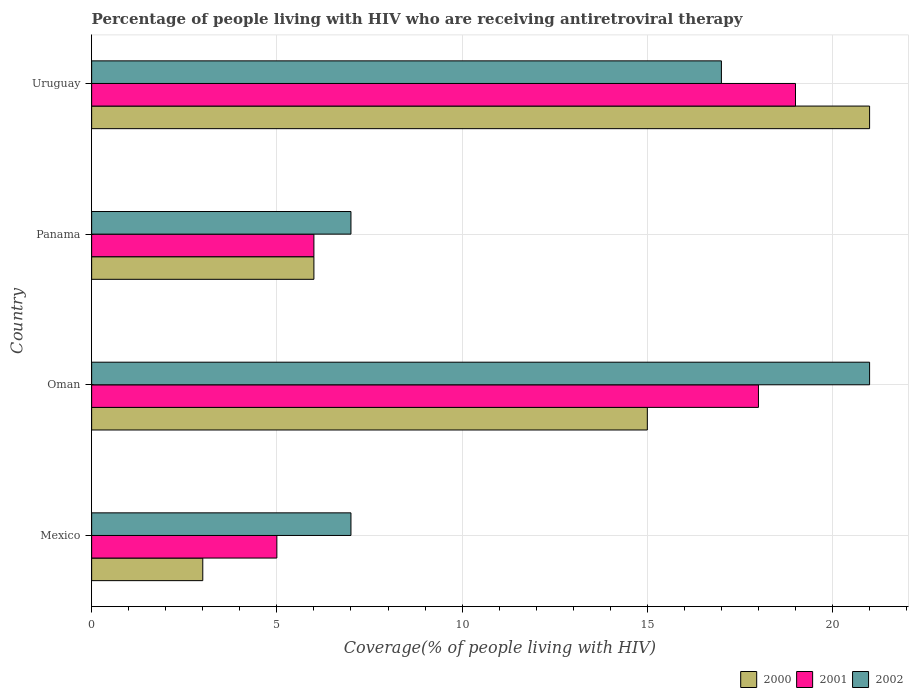How many groups of bars are there?
Offer a very short reply. 4. Are the number of bars per tick equal to the number of legend labels?
Your response must be concise. Yes. Are the number of bars on each tick of the Y-axis equal?
Offer a terse response. Yes. What is the label of the 2nd group of bars from the top?
Make the answer very short. Panama. In how many cases, is the number of bars for a given country not equal to the number of legend labels?
Ensure brevity in your answer.  0. What is the percentage of the HIV infected people who are receiving antiretroviral therapy in 2002 in Oman?
Give a very brief answer. 21. In which country was the percentage of the HIV infected people who are receiving antiretroviral therapy in 2001 maximum?
Ensure brevity in your answer.  Uruguay. What is the total percentage of the HIV infected people who are receiving antiretroviral therapy in 2000 in the graph?
Provide a short and direct response. 45. What is the difference between the percentage of the HIV infected people who are receiving antiretroviral therapy in 2000 in Oman and that in Panama?
Make the answer very short. 9. What is the average percentage of the HIV infected people who are receiving antiretroviral therapy in 2000 per country?
Offer a terse response. 11.25. In how many countries, is the percentage of the HIV infected people who are receiving antiretroviral therapy in 2001 greater than 5 %?
Your response must be concise. 3. What is the ratio of the percentage of the HIV infected people who are receiving antiretroviral therapy in 2002 in Mexico to that in Oman?
Offer a very short reply. 0.33. Is the percentage of the HIV infected people who are receiving antiretroviral therapy in 2001 in Oman less than that in Uruguay?
Offer a very short reply. Yes. What does the 2nd bar from the top in Oman represents?
Ensure brevity in your answer.  2001. Is it the case that in every country, the sum of the percentage of the HIV infected people who are receiving antiretroviral therapy in 2002 and percentage of the HIV infected people who are receiving antiretroviral therapy in 2000 is greater than the percentage of the HIV infected people who are receiving antiretroviral therapy in 2001?
Your response must be concise. Yes. Are all the bars in the graph horizontal?
Ensure brevity in your answer.  Yes. What is the difference between two consecutive major ticks on the X-axis?
Your answer should be compact. 5. Does the graph contain any zero values?
Your response must be concise. No. What is the title of the graph?
Your answer should be very brief. Percentage of people living with HIV who are receiving antiretroviral therapy. Does "1970" appear as one of the legend labels in the graph?
Provide a short and direct response. No. What is the label or title of the X-axis?
Your answer should be compact. Coverage(% of people living with HIV). What is the label or title of the Y-axis?
Keep it short and to the point. Country. What is the Coverage(% of people living with HIV) in 2002 in Mexico?
Offer a very short reply. 7. What is the Coverage(% of people living with HIV) in 2000 in Oman?
Offer a terse response. 15. What is the Coverage(% of people living with HIV) of 2001 in Oman?
Make the answer very short. 18. What is the Coverage(% of people living with HIV) of 2001 in Panama?
Offer a very short reply. 6. What is the Coverage(% of people living with HIV) of 2000 in Uruguay?
Make the answer very short. 21. What is the Coverage(% of people living with HIV) of 2002 in Uruguay?
Your response must be concise. 17. Across all countries, what is the maximum Coverage(% of people living with HIV) in 2000?
Provide a short and direct response. 21. Across all countries, what is the minimum Coverage(% of people living with HIV) in 2000?
Ensure brevity in your answer.  3. Across all countries, what is the minimum Coverage(% of people living with HIV) in 2001?
Offer a very short reply. 5. What is the total Coverage(% of people living with HIV) of 2002 in the graph?
Offer a terse response. 52. What is the difference between the Coverage(% of people living with HIV) of 2001 in Mexico and that in Oman?
Make the answer very short. -13. What is the difference between the Coverage(% of people living with HIV) of 2000 in Mexico and that in Panama?
Give a very brief answer. -3. What is the difference between the Coverage(% of people living with HIV) of 2001 in Mexico and that in Panama?
Provide a succinct answer. -1. What is the difference between the Coverage(% of people living with HIV) of 2002 in Mexico and that in Uruguay?
Offer a very short reply. -10. What is the difference between the Coverage(% of people living with HIV) in 2000 in Oman and that in Panama?
Offer a terse response. 9. What is the difference between the Coverage(% of people living with HIV) of 2001 in Oman and that in Panama?
Offer a very short reply. 12. What is the difference between the Coverage(% of people living with HIV) in 2002 in Oman and that in Uruguay?
Your response must be concise. 4. What is the difference between the Coverage(% of people living with HIV) in 2001 in Panama and that in Uruguay?
Your response must be concise. -13. What is the difference between the Coverage(% of people living with HIV) of 2002 in Panama and that in Uruguay?
Offer a terse response. -10. What is the difference between the Coverage(% of people living with HIV) in 2000 in Mexico and the Coverage(% of people living with HIV) in 2002 in Oman?
Make the answer very short. -18. What is the difference between the Coverage(% of people living with HIV) of 2000 in Mexico and the Coverage(% of people living with HIV) of 2001 in Panama?
Your answer should be very brief. -3. What is the difference between the Coverage(% of people living with HIV) in 2000 in Mexico and the Coverage(% of people living with HIV) in 2002 in Panama?
Offer a very short reply. -4. What is the difference between the Coverage(% of people living with HIV) in 2001 in Mexico and the Coverage(% of people living with HIV) in 2002 in Panama?
Give a very brief answer. -2. What is the difference between the Coverage(% of people living with HIV) of 2000 in Oman and the Coverage(% of people living with HIV) of 2001 in Panama?
Give a very brief answer. 9. What is the difference between the Coverage(% of people living with HIV) of 2000 in Oman and the Coverage(% of people living with HIV) of 2002 in Panama?
Provide a succinct answer. 8. What is the difference between the Coverage(% of people living with HIV) of 2001 in Oman and the Coverage(% of people living with HIV) of 2002 in Panama?
Offer a terse response. 11. What is the difference between the Coverage(% of people living with HIV) of 2000 in Oman and the Coverage(% of people living with HIV) of 2001 in Uruguay?
Offer a terse response. -4. What is the average Coverage(% of people living with HIV) of 2000 per country?
Offer a very short reply. 11.25. What is the average Coverage(% of people living with HIV) of 2001 per country?
Give a very brief answer. 12. What is the difference between the Coverage(% of people living with HIV) of 2000 and Coverage(% of people living with HIV) of 2002 in Mexico?
Give a very brief answer. -4. What is the difference between the Coverage(% of people living with HIV) in 2000 and Coverage(% of people living with HIV) in 2001 in Oman?
Offer a terse response. -3. What is the difference between the Coverage(% of people living with HIV) in 2000 and Coverage(% of people living with HIV) in 2002 in Oman?
Give a very brief answer. -6. What is the difference between the Coverage(% of people living with HIV) of 2001 and Coverage(% of people living with HIV) of 2002 in Panama?
Offer a very short reply. -1. What is the difference between the Coverage(% of people living with HIV) in 2000 and Coverage(% of people living with HIV) in 2001 in Uruguay?
Give a very brief answer. 2. What is the difference between the Coverage(% of people living with HIV) in 2000 and Coverage(% of people living with HIV) in 2002 in Uruguay?
Provide a succinct answer. 4. What is the ratio of the Coverage(% of people living with HIV) of 2001 in Mexico to that in Oman?
Your answer should be very brief. 0.28. What is the ratio of the Coverage(% of people living with HIV) in 2002 in Mexico to that in Oman?
Provide a short and direct response. 0.33. What is the ratio of the Coverage(% of people living with HIV) of 2000 in Mexico to that in Panama?
Your response must be concise. 0.5. What is the ratio of the Coverage(% of people living with HIV) of 2001 in Mexico to that in Panama?
Provide a succinct answer. 0.83. What is the ratio of the Coverage(% of people living with HIV) of 2000 in Mexico to that in Uruguay?
Ensure brevity in your answer.  0.14. What is the ratio of the Coverage(% of people living with HIV) of 2001 in Mexico to that in Uruguay?
Provide a succinct answer. 0.26. What is the ratio of the Coverage(% of people living with HIV) in 2002 in Mexico to that in Uruguay?
Offer a very short reply. 0.41. What is the ratio of the Coverage(% of people living with HIV) of 2000 in Oman to that in Panama?
Give a very brief answer. 2.5. What is the ratio of the Coverage(% of people living with HIV) of 2000 in Oman to that in Uruguay?
Offer a very short reply. 0.71. What is the ratio of the Coverage(% of people living with HIV) in 2002 in Oman to that in Uruguay?
Ensure brevity in your answer.  1.24. What is the ratio of the Coverage(% of people living with HIV) of 2000 in Panama to that in Uruguay?
Offer a very short reply. 0.29. What is the ratio of the Coverage(% of people living with HIV) of 2001 in Panama to that in Uruguay?
Your answer should be very brief. 0.32. What is the ratio of the Coverage(% of people living with HIV) of 2002 in Panama to that in Uruguay?
Offer a very short reply. 0.41. What is the difference between the highest and the second highest Coverage(% of people living with HIV) in 2000?
Provide a short and direct response. 6. What is the difference between the highest and the lowest Coverage(% of people living with HIV) in 2001?
Offer a very short reply. 14. What is the difference between the highest and the lowest Coverage(% of people living with HIV) of 2002?
Give a very brief answer. 14. 